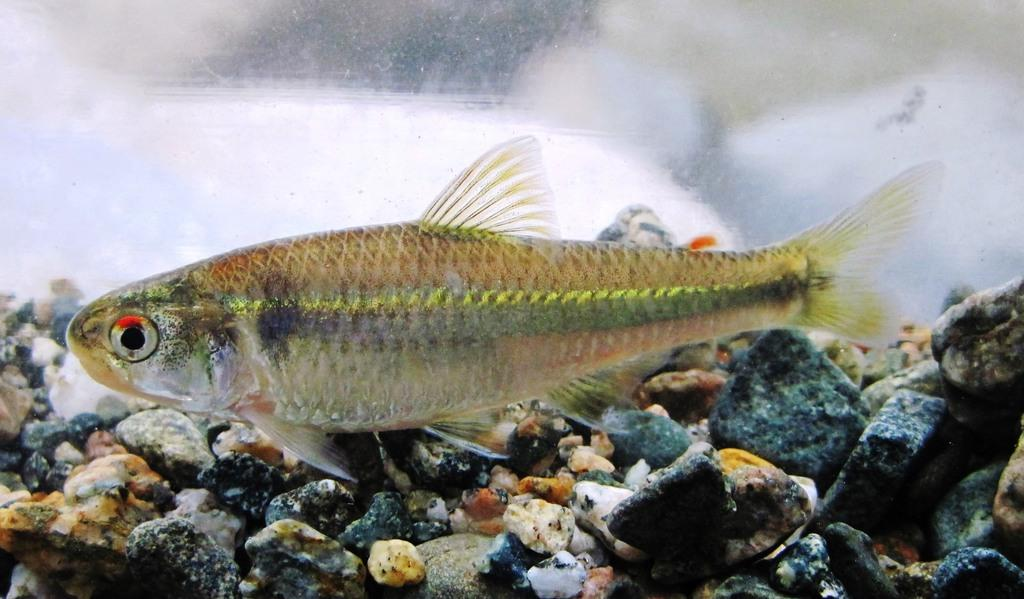What is the main subject of the image? The image depicts a water body. Can you identify any living creatures in the water? Yes, there is a fish visible in the water. What can be seen at the bottom of the water body? There are stones at the bottom of the water body. What type of soup is being prepared in the image? There is no soup present in the image; it depicts a water body with a fish and stones at the bottom. 